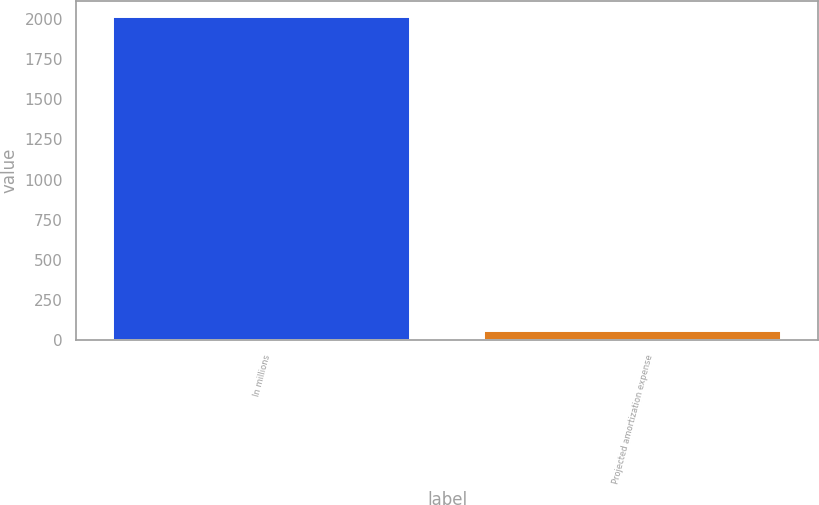<chart> <loc_0><loc_0><loc_500><loc_500><bar_chart><fcel>In millions<fcel>Projected amortization expense<nl><fcel>2011<fcel>60<nl></chart> 